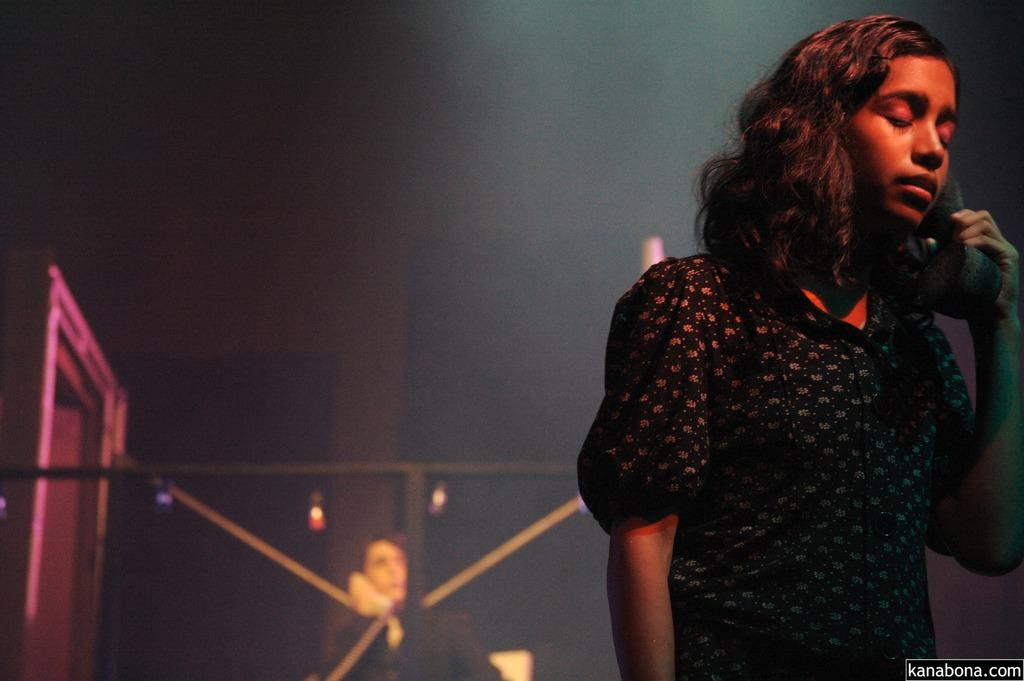What are the two women in the image doing? The first woman is standing and speaking on a phone, while the second woman is sitting and speaking on a phone. Can you describe the background of the image? There is a door visible in the background. What can be seen in terms of lighting in the image? There are lights visible in the image. What type of basket is being used to collect dust in the image? There is no basket or dust present in the image. What type of approval is being sought by the women in the image? There is no indication in the image that the women are seeking any type of approval. 